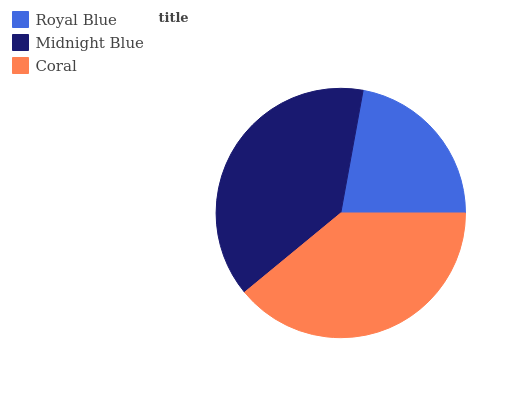Is Royal Blue the minimum?
Answer yes or no. Yes. Is Coral the maximum?
Answer yes or no. Yes. Is Midnight Blue the minimum?
Answer yes or no. No. Is Midnight Blue the maximum?
Answer yes or no. No. Is Midnight Blue greater than Royal Blue?
Answer yes or no. Yes. Is Royal Blue less than Midnight Blue?
Answer yes or no. Yes. Is Royal Blue greater than Midnight Blue?
Answer yes or no. No. Is Midnight Blue less than Royal Blue?
Answer yes or no. No. Is Midnight Blue the high median?
Answer yes or no. Yes. Is Midnight Blue the low median?
Answer yes or no. Yes. Is Coral the high median?
Answer yes or no. No. Is Royal Blue the low median?
Answer yes or no. No. 